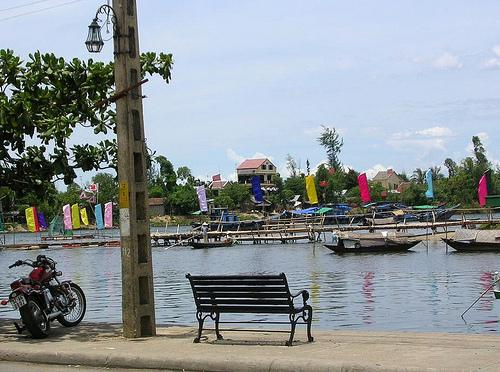Question: what is next to the bench?
Choices:
A. A bicycle.
B. A statue.
C. A motorcycle.
D. A stop sign.
Answer with the letter. Answer: C Question: what color is the roof?
Choices:
A. Brown.
B. Black.
C. Grey.
D. Red.
Answer with the letter. Answer: D Question: why are there a lot of flags?
Choices:
A. Because it's an embassy.
B. Because it's the 4th of July.
C. Because this is a flag store.
D. Because of the festival.
Answer with the letter. Answer: D 